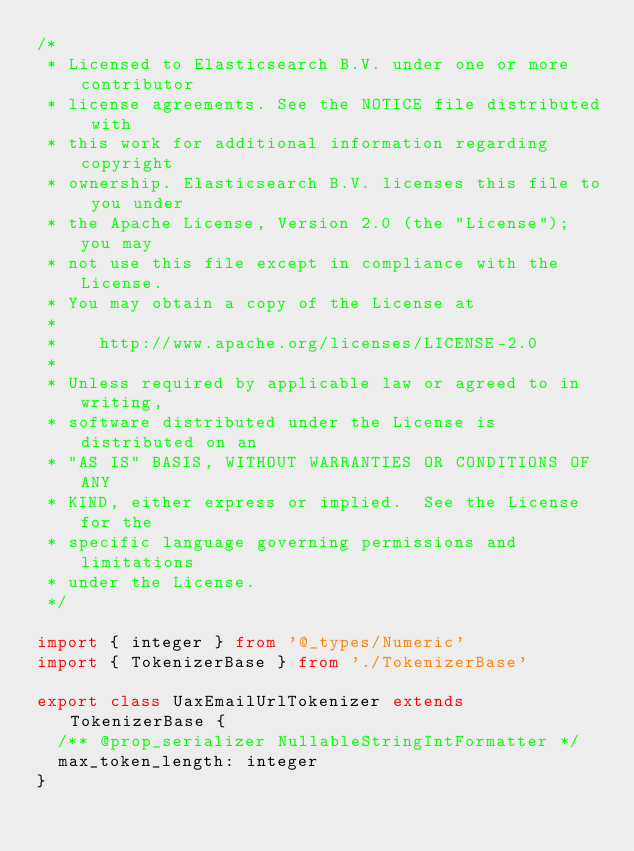<code> <loc_0><loc_0><loc_500><loc_500><_TypeScript_>/*
 * Licensed to Elasticsearch B.V. under one or more contributor
 * license agreements. See the NOTICE file distributed with
 * this work for additional information regarding copyright
 * ownership. Elasticsearch B.V. licenses this file to you under
 * the Apache License, Version 2.0 (the "License"); you may
 * not use this file except in compliance with the License.
 * You may obtain a copy of the License at
 *
 *    http://www.apache.org/licenses/LICENSE-2.0
 *
 * Unless required by applicable law or agreed to in writing,
 * software distributed under the License is distributed on an
 * "AS IS" BASIS, WITHOUT WARRANTIES OR CONDITIONS OF ANY
 * KIND, either express or implied.  See the License for the
 * specific language governing permissions and limitations
 * under the License.
 */

import { integer } from '@_types/Numeric'
import { TokenizerBase } from './TokenizerBase'

export class UaxEmailUrlTokenizer extends TokenizerBase {
  /** @prop_serializer NullableStringIntFormatter */
  max_token_length: integer
}
</code> 